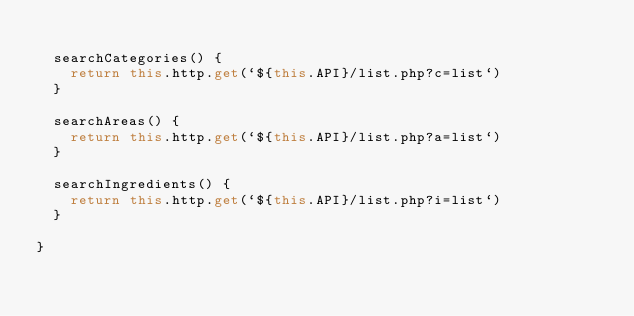Convert code to text. <code><loc_0><loc_0><loc_500><loc_500><_TypeScript_>
  searchCategories() {
    return this.http.get(`${this.API}/list.php?c=list`)
  }

  searchAreas() {
    return this.http.get(`${this.API}/list.php?a=list`)
  }

  searchIngredients() {
    return this.http.get(`${this.API}/list.php?i=list`)
  }

}
</code> 